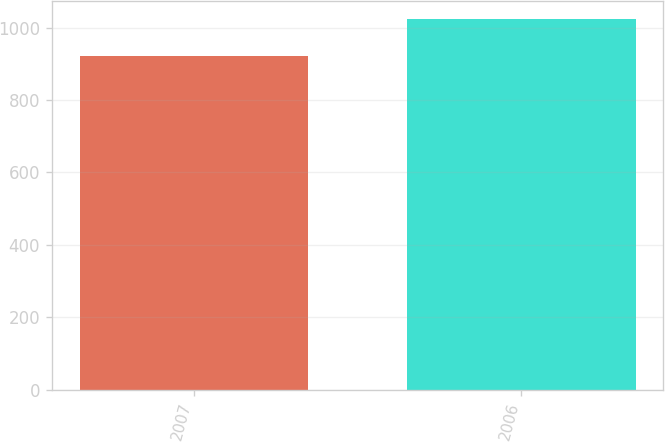<chart> <loc_0><loc_0><loc_500><loc_500><bar_chart><fcel>2007<fcel>2006<nl><fcel>922<fcel>1023<nl></chart> 